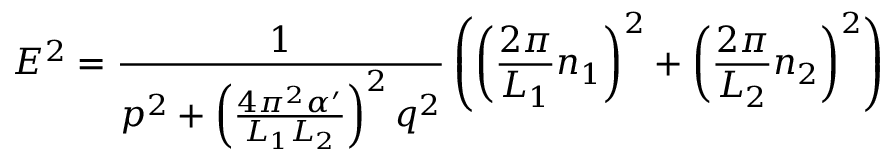<formula> <loc_0><loc_0><loc_500><loc_500>E ^ { 2 } = \frac { 1 } { p ^ { 2 } + \left ( \frac { 4 \pi ^ { 2 } \alpha ^ { \prime } } { L _ { 1 } L _ { 2 } } \right ) ^ { 2 } q ^ { 2 } } \left ( \left ( \frac { 2 \pi } { L _ { 1 } } n _ { 1 } \right ) ^ { 2 } + \left ( \frac { 2 \pi } { L _ { 2 } } n _ { 2 } \right ) ^ { 2 } \right )</formula> 